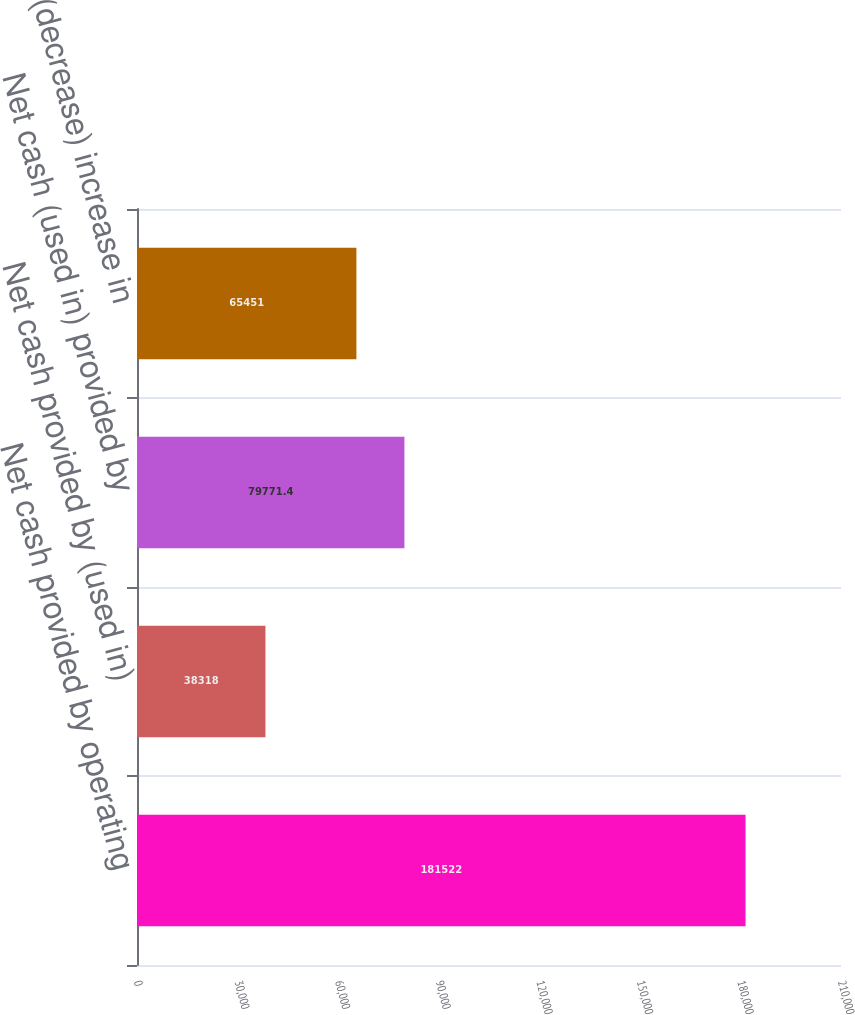Convert chart. <chart><loc_0><loc_0><loc_500><loc_500><bar_chart><fcel>Net cash provided by operating<fcel>Net cash provided by (used in)<fcel>Net cash (used in) provided by<fcel>Net (decrease) increase in<nl><fcel>181522<fcel>38318<fcel>79771.4<fcel>65451<nl></chart> 